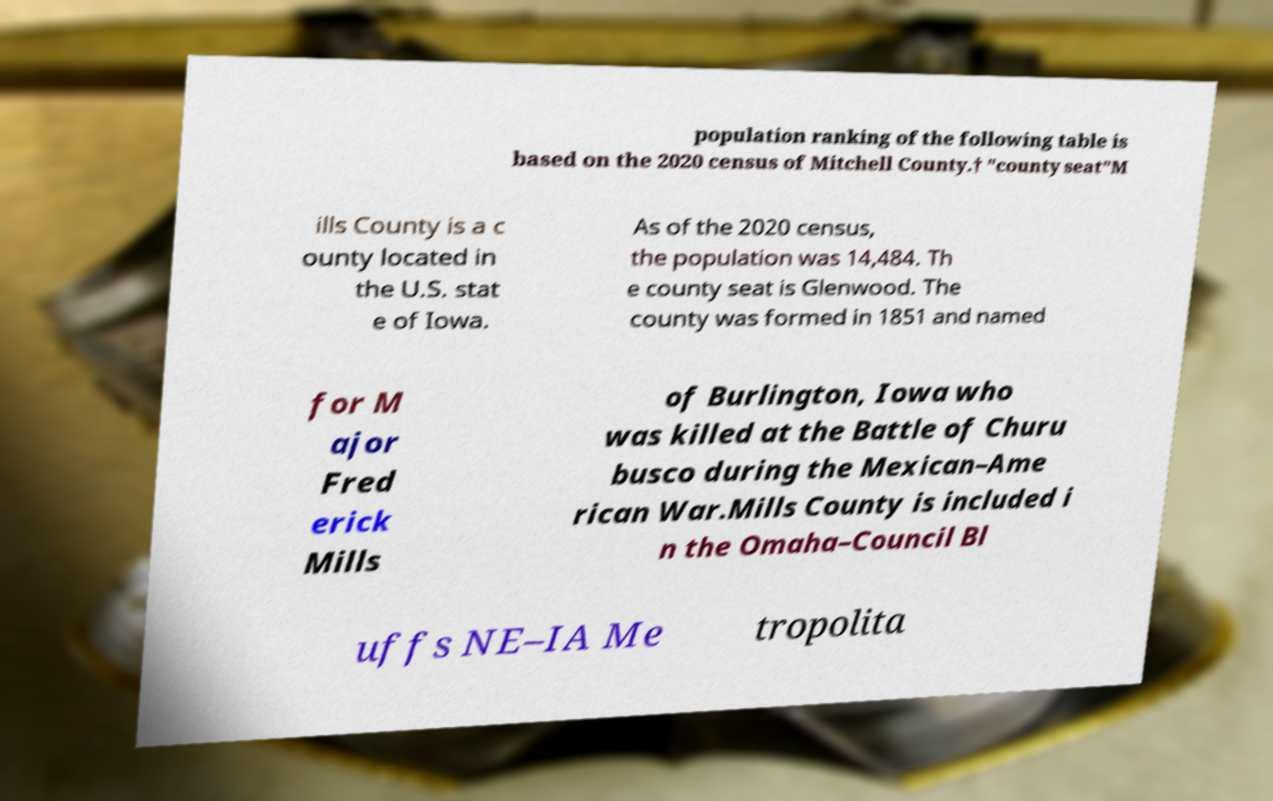Can you accurately transcribe the text from the provided image for me? population ranking of the following table is based on the 2020 census of Mitchell County.† "county seat"M ills County is a c ounty located in the U.S. stat e of Iowa. As of the 2020 census, the population was 14,484. Th e county seat is Glenwood. The county was formed in 1851 and named for M ajor Fred erick Mills of Burlington, Iowa who was killed at the Battle of Churu busco during the Mexican–Ame rican War.Mills County is included i n the Omaha–Council Bl uffs NE–IA Me tropolita 